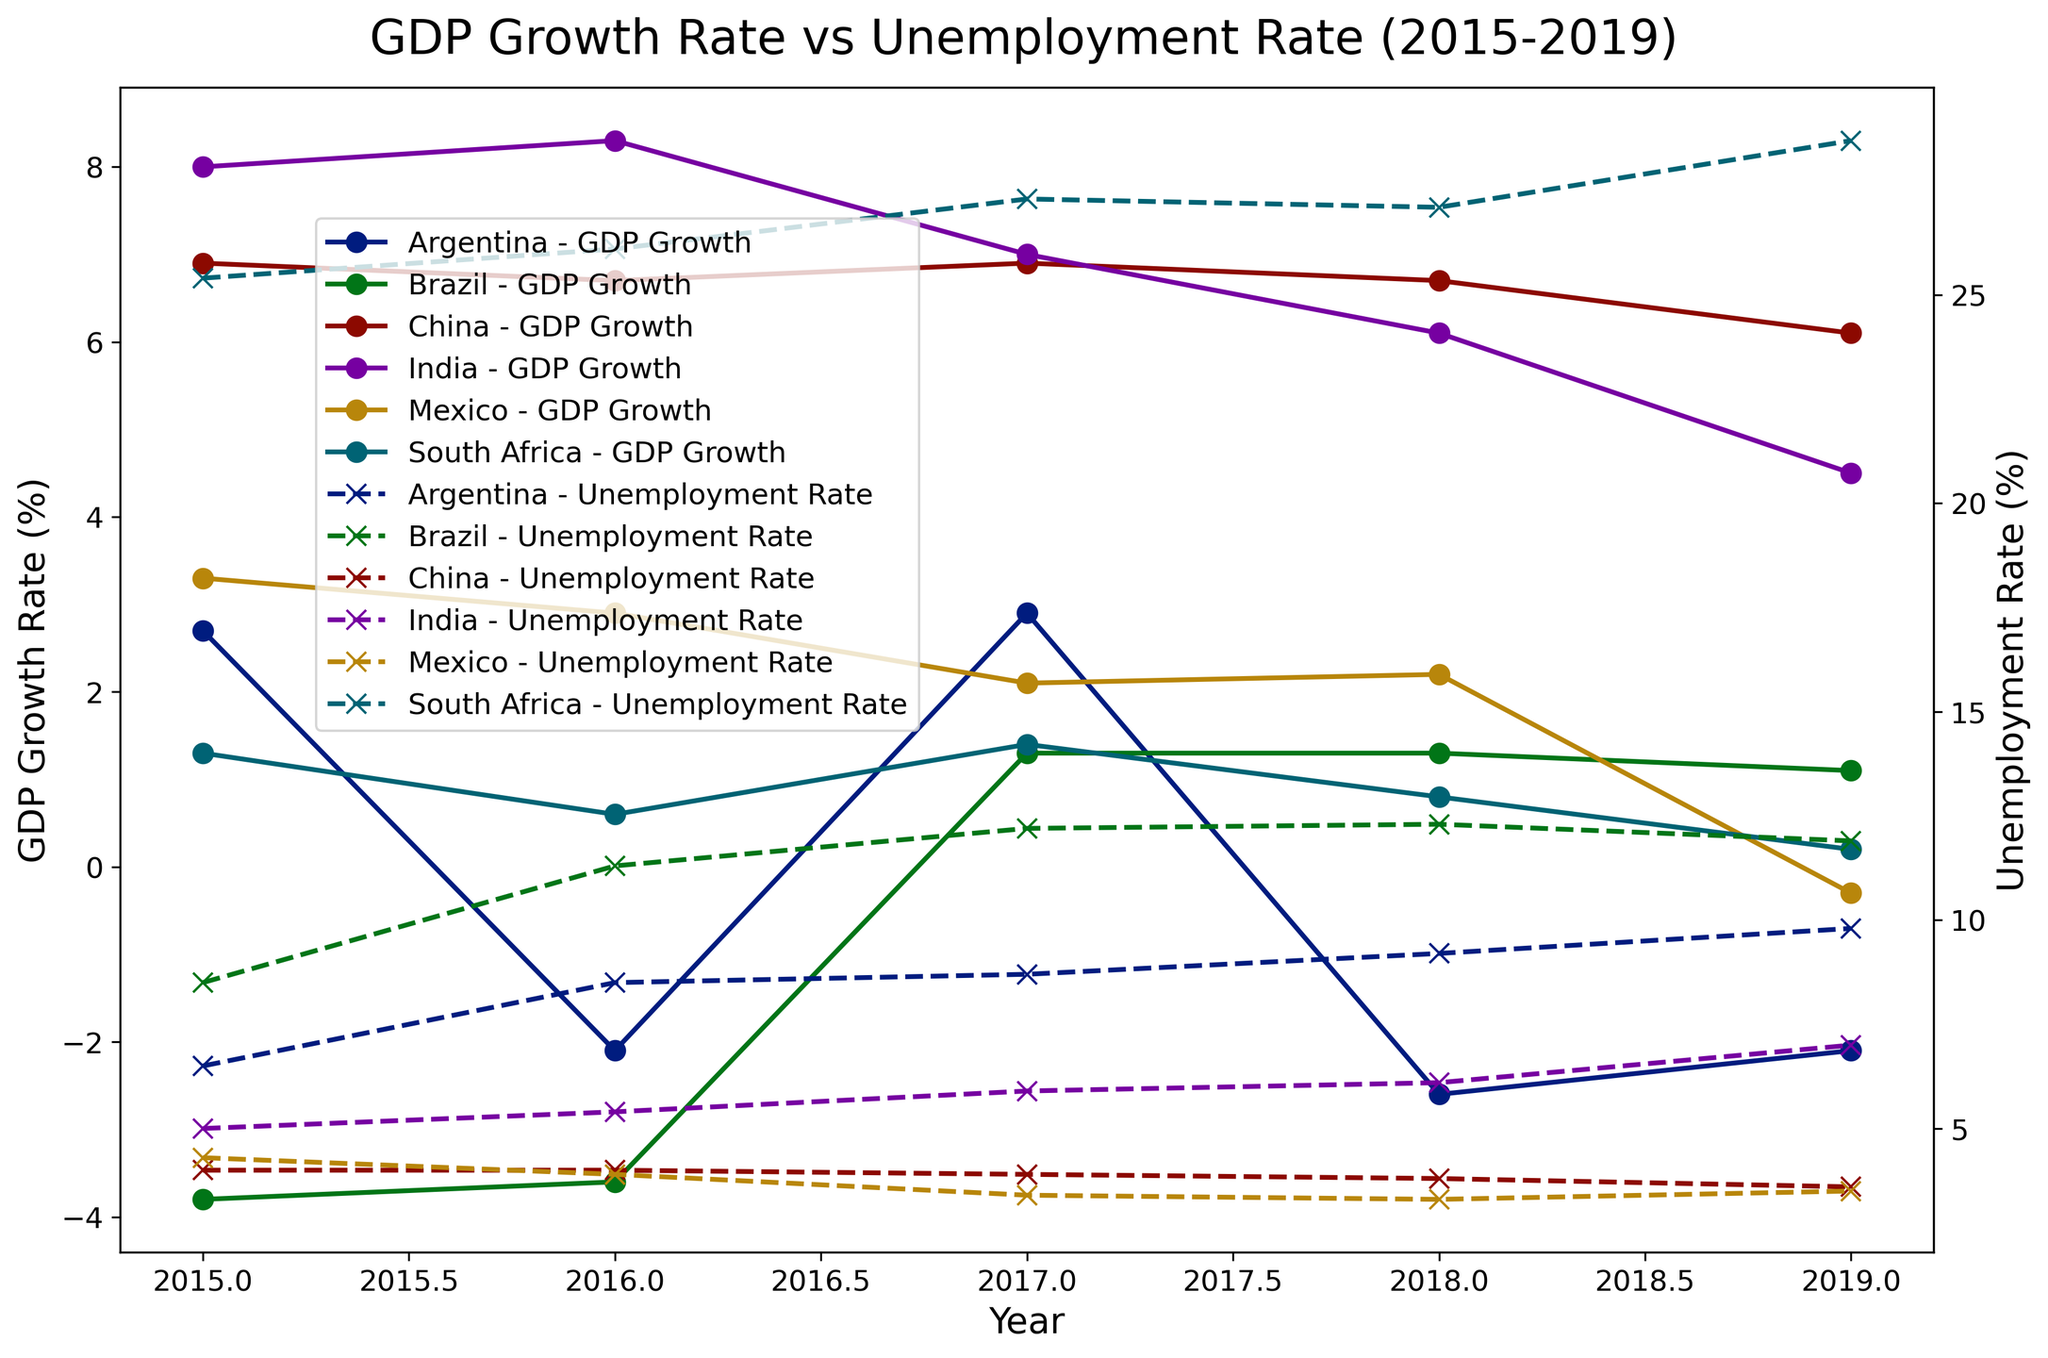Which country had the highest GDP growth rate in 2015? To find the highest GDP growth rate in 2015, examine the GDP Growth Rate lines for each country for the year 2015. India's line peaks at 8.0%, the highest among all countries.
Answer: India What trend did the unemployment rate in South Africa follow from 2015 to 2019? To determine the trend, look at the Unemployment Rate line for South Africa from 2015 to 2019. The line shows an overall upward trend, starting from 25.4% in 2015 and rising to 28.7% in 2019.
Answer: Upward trend Compare China's GDP growth rate and unemployment rate in 2017. Identify the points on China’s GDP Growth Rate and Unemployment Rate lines for the year 2017. The GDP growth rate is 6.9%, and the unemployment rate is 3.9%.
Answer: 6.9% for GDP growth rate, 3.9% for unemployment rate Which country saw the most significant improvement in GDP growth rate between 2016 and 2017? To find the most significant improvement, calculate the difference in GDP growth rate for each country between 2016 and 2017. Argentina improved from -2.1% to 2.9%, a difference of 5.0%.
Answer: Argentina How did the economic performance of Brazil change from 2015 to 2019 based on GDP growth rate and unemployment rate? To evaluate the economic performance, look at Brazil's GDP Growth Rate and Unemployment Rate lines from 2015 to 2019. The GDP growth rate improved from -3.8% to 1.1%, while the unemployment rate increased from 8.5% to 11.9%.
Answer: GDP growth improved, unemployment worsened In which year did India experience the highest increase in unemployment rate? Examine the Unemployment Rate line for India and identify the year with the steepest rise. The largest increase is seen between 2018 (6.1%) and 2019 (7.0%).
Answer: 2019 What is the correlation between GDP growth rate and unemployment rate for Mexico from 2015 to 2019? To identify the correlation, observe the trend lines of GDP Growth Rate and Unemployment Rate for Mexico. As GDP growth rate declined, the unemployment rate also decreased slightly, suggesting a very weak or no clear correlation.
Answer: Weak or no correlation Which country maintained a steady unemployment rate throughout the years 2015 to 2019? Look for the country whose unemployment rate line shows minimal fluctuation. China’s unemployment rate remains steady, slightly declining from 4.0% in 2015 to 3.6% in 2019.
Answer: China 